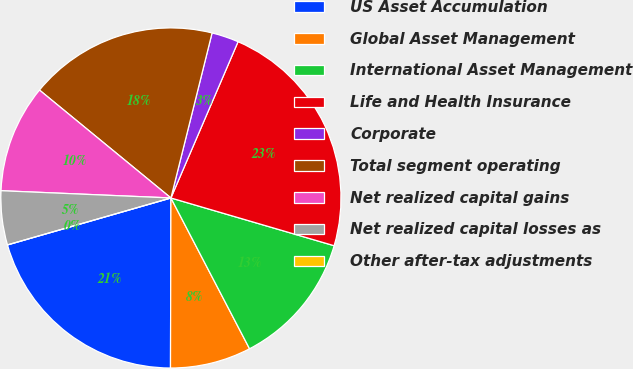<chart> <loc_0><loc_0><loc_500><loc_500><pie_chart><fcel>US Asset Accumulation<fcel>Global Asset Management<fcel>International Asset Management<fcel>Life and Health Insurance<fcel>Corporate<fcel>Total segment operating<fcel>Net realized capital gains<fcel>Net realized capital losses as<fcel>Other after-tax adjustments<nl><fcel>20.51%<fcel>7.69%<fcel>12.82%<fcel>23.07%<fcel>2.57%<fcel>17.95%<fcel>10.26%<fcel>5.13%<fcel>0.0%<nl></chart> 